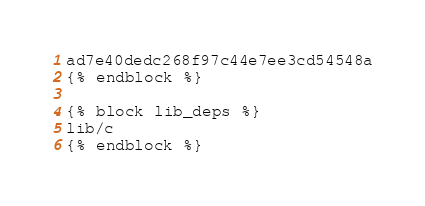Convert code to text. <code><loc_0><loc_0><loc_500><loc_500><_Bash_>ad7e40dedc268f97c44e7ee3cd54548a
{% endblock %}

{% block lib_deps %}
lib/c
{% endblock %}
</code> 